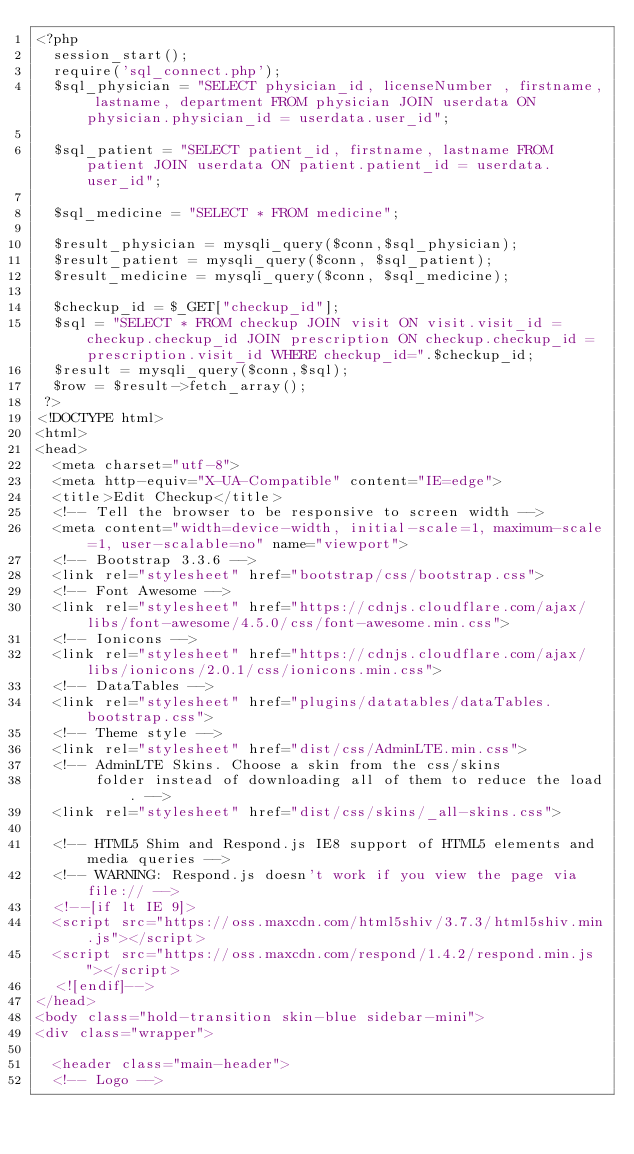<code> <loc_0><loc_0><loc_500><loc_500><_PHP_><?php 
  session_start();
  require('sql_connect.php');
  $sql_physician = "SELECT physician_id, licenseNumber , firstname, lastname, department FROM physician JOIN userdata ON physician.physician_id = userdata.user_id";

  $sql_patient = "SELECT patient_id, firstname, lastname FROM patient JOIN userdata ON patient.patient_id = userdata.user_id";

  $sql_medicine = "SELECT * FROM medicine";

  $result_physician = mysqli_query($conn,$sql_physician);
  $result_patient = mysqli_query($conn, $sql_patient);
  $result_medicine = mysqli_query($conn, $sql_medicine);

  $checkup_id = $_GET["checkup_id"];
  $sql = "SELECT * FROM checkup JOIN visit ON visit.visit_id = checkup.checkup_id JOIN prescription ON checkup.checkup_id = prescription.visit_id WHERE checkup_id=".$checkup_id;
  $result = mysqli_query($conn,$sql);
  $row = $result->fetch_array();
 ?>
<!DOCTYPE html>
<html>
<head>
  <meta charset="utf-8">
  <meta http-equiv="X-UA-Compatible" content="IE=edge">
  <title>Edit Checkup</title>
  <!-- Tell the browser to be responsive to screen width -->
  <meta content="width=device-width, initial-scale=1, maximum-scale=1, user-scalable=no" name="viewport">
  <!-- Bootstrap 3.3.6 -->
  <link rel="stylesheet" href="bootstrap/css/bootstrap.css">
  <!-- Font Awesome -->
  <link rel="stylesheet" href="https://cdnjs.cloudflare.com/ajax/libs/font-awesome/4.5.0/css/font-awesome.min.css">
  <!-- Ionicons -->
  <link rel="stylesheet" href="https://cdnjs.cloudflare.com/ajax/libs/ionicons/2.0.1/css/ionicons.min.css">
  <!-- DataTables -->
  <link rel="stylesheet" href="plugins/datatables/dataTables.bootstrap.css">
  <!-- Theme style -->
  <link rel="stylesheet" href="dist/css/AdminLTE.min.css">
  <!-- AdminLTE Skins. Choose a skin from the css/skins
       folder instead of downloading all of them to reduce the load. -->
  <link rel="stylesheet" href="dist/css/skins/_all-skins.css">

  <!-- HTML5 Shim and Respond.js IE8 support of HTML5 elements and media queries -->
  <!-- WARNING: Respond.js doesn't work if you view the page via file:// -->
  <!--[if lt IE 9]>
  <script src="https://oss.maxcdn.com/html5shiv/3.7.3/html5shiv.min.js"></script>
  <script src="https://oss.maxcdn.com/respond/1.4.2/respond.min.js"></script>
  <![endif]-->
</head>
<body class="hold-transition skin-blue sidebar-mini">
<div class="wrapper">

  <header class="main-header">
  <!-- Logo --></code> 